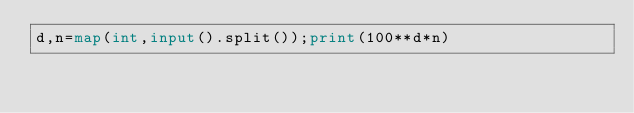Convert code to text. <code><loc_0><loc_0><loc_500><loc_500><_Python_>d,n=map(int,input().split());print(100**d*n)</code> 